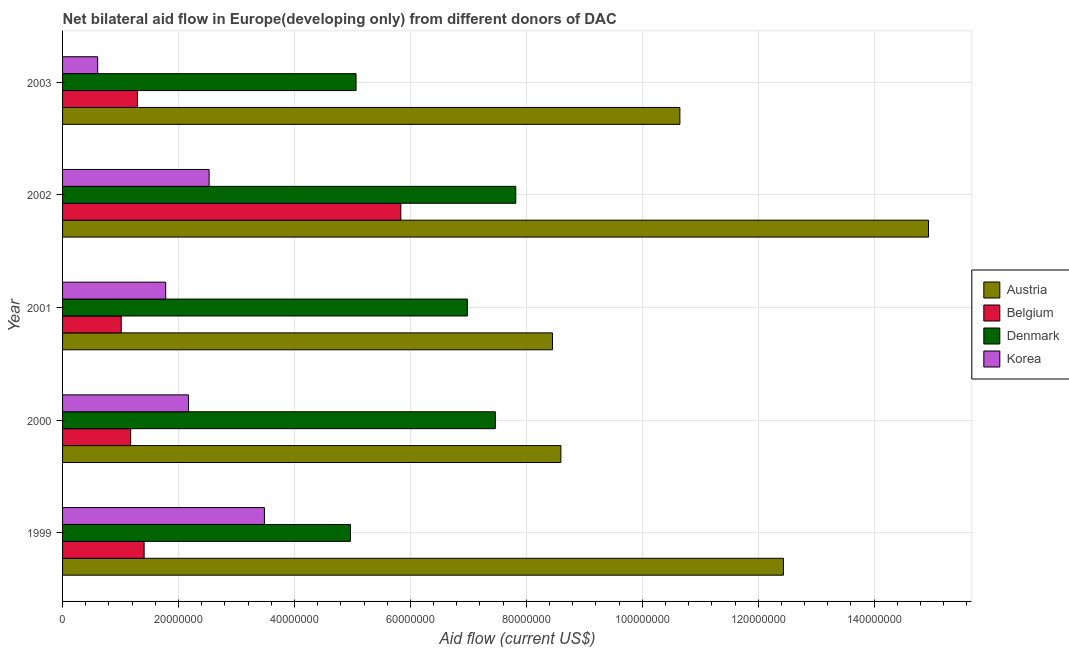How many bars are there on the 1st tick from the top?
Make the answer very short. 4. In how many cases, is the number of bars for a given year not equal to the number of legend labels?
Ensure brevity in your answer.  0. What is the amount of aid given by austria in 2000?
Offer a terse response. 8.60e+07. Across all years, what is the maximum amount of aid given by austria?
Provide a succinct answer. 1.49e+08. Across all years, what is the minimum amount of aid given by austria?
Give a very brief answer. 8.45e+07. What is the total amount of aid given by austria in the graph?
Your answer should be compact. 5.51e+08. What is the difference between the amount of aid given by austria in 2000 and that in 2001?
Your answer should be very brief. 1.44e+06. What is the difference between the amount of aid given by belgium in 2001 and the amount of aid given by korea in 1999?
Your answer should be compact. -2.47e+07. What is the average amount of aid given by belgium per year?
Give a very brief answer. 2.14e+07. In the year 2000, what is the difference between the amount of aid given by korea and amount of aid given by austria?
Ensure brevity in your answer.  -6.42e+07. What is the ratio of the amount of aid given by austria in 2001 to that in 2002?
Your answer should be compact. 0.57. Is the amount of aid given by belgium in 2001 less than that in 2002?
Make the answer very short. Yes. What is the difference between the highest and the second highest amount of aid given by denmark?
Give a very brief answer. 3.52e+06. What is the difference between the highest and the lowest amount of aid given by belgium?
Offer a terse response. 4.82e+07. Is the sum of the amount of aid given by denmark in 2002 and 2003 greater than the maximum amount of aid given by korea across all years?
Keep it short and to the point. Yes. Is it the case that in every year, the sum of the amount of aid given by austria and amount of aid given by denmark is greater than the sum of amount of aid given by korea and amount of aid given by belgium?
Your response must be concise. Yes. What does the 1st bar from the top in 2003 represents?
Make the answer very short. Korea. What does the 3rd bar from the bottom in 2000 represents?
Ensure brevity in your answer.  Denmark. How many bars are there?
Provide a short and direct response. 20. How many years are there in the graph?
Ensure brevity in your answer.  5. Are the values on the major ticks of X-axis written in scientific E-notation?
Your answer should be compact. No. Does the graph contain any zero values?
Ensure brevity in your answer.  No. Does the graph contain grids?
Ensure brevity in your answer.  Yes. Where does the legend appear in the graph?
Ensure brevity in your answer.  Center right. What is the title of the graph?
Provide a short and direct response. Net bilateral aid flow in Europe(developing only) from different donors of DAC. What is the label or title of the Y-axis?
Your answer should be compact. Year. What is the Aid flow (current US$) of Austria in 1999?
Your answer should be compact. 1.24e+08. What is the Aid flow (current US$) of Belgium in 1999?
Make the answer very short. 1.41e+07. What is the Aid flow (current US$) of Denmark in 1999?
Offer a terse response. 4.97e+07. What is the Aid flow (current US$) in Korea in 1999?
Your response must be concise. 3.48e+07. What is the Aid flow (current US$) of Austria in 2000?
Keep it short and to the point. 8.60e+07. What is the Aid flow (current US$) in Belgium in 2000?
Ensure brevity in your answer.  1.18e+07. What is the Aid flow (current US$) in Denmark in 2000?
Give a very brief answer. 7.47e+07. What is the Aid flow (current US$) of Korea in 2000?
Your response must be concise. 2.17e+07. What is the Aid flow (current US$) of Austria in 2001?
Your answer should be compact. 8.45e+07. What is the Aid flow (current US$) of Belgium in 2001?
Provide a short and direct response. 1.01e+07. What is the Aid flow (current US$) of Denmark in 2001?
Make the answer very short. 6.98e+07. What is the Aid flow (current US$) of Korea in 2001?
Your answer should be compact. 1.78e+07. What is the Aid flow (current US$) of Austria in 2002?
Ensure brevity in your answer.  1.49e+08. What is the Aid flow (current US$) in Belgium in 2002?
Keep it short and to the point. 5.84e+07. What is the Aid flow (current US$) of Denmark in 2002?
Give a very brief answer. 7.82e+07. What is the Aid flow (current US$) of Korea in 2002?
Give a very brief answer. 2.53e+07. What is the Aid flow (current US$) of Austria in 2003?
Ensure brevity in your answer.  1.06e+08. What is the Aid flow (current US$) of Belgium in 2003?
Provide a succinct answer. 1.29e+07. What is the Aid flow (current US$) of Denmark in 2003?
Provide a succinct answer. 5.06e+07. What is the Aid flow (current US$) of Korea in 2003?
Offer a terse response. 6.06e+06. Across all years, what is the maximum Aid flow (current US$) of Austria?
Your answer should be compact. 1.49e+08. Across all years, what is the maximum Aid flow (current US$) of Belgium?
Make the answer very short. 5.84e+07. Across all years, what is the maximum Aid flow (current US$) in Denmark?
Your answer should be compact. 7.82e+07. Across all years, what is the maximum Aid flow (current US$) of Korea?
Offer a very short reply. 3.48e+07. Across all years, what is the minimum Aid flow (current US$) in Austria?
Offer a very short reply. 8.45e+07. Across all years, what is the minimum Aid flow (current US$) of Belgium?
Your answer should be compact. 1.01e+07. Across all years, what is the minimum Aid flow (current US$) of Denmark?
Offer a very short reply. 4.97e+07. Across all years, what is the minimum Aid flow (current US$) of Korea?
Give a very brief answer. 6.06e+06. What is the total Aid flow (current US$) of Austria in the graph?
Offer a very short reply. 5.51e+08. What is the total Aid flow (current US$) in Belgium in the graph?
Offer a terse response. 1.07e+08. What is the total Aid flow (current US$) of Denmark in the graph?
Your answer should be very brief. 3.23e+08. What is the total Aid flow (current US$) of Korea in the graph?
Keep it short and to the point. 1.06e+08. What is the difference between the Aid flow (current US$) in Austria in 1999 and that in 2000?
Provide a short and direct response. 3.84e+07. What is the difference between the Aid flow (current US$) of Belgium in 1999 and that in 2000?
Keep it short and to the point. 2.32e+06. What is the difference between the Aid flow (current US$) in Denmark in 1999 and that in 2000?
Keep it short and to the point. -2.50e+07. What is the difference between the Aid flow (current US$) in Korea in 1999 and that in 2000?
Provide a short and direct response. 1.31e+07. What is the difference between the Aid flow (current US$) in Austria in 1999 and that in 2001?
Provide a short and direct response. 3.98e+07. What is the difference between the Aid flow (current US$) in Belgium in 1999 and that in 2001?
Provide a short and direct response. 3.95e+06. What is the difference between the Aid flow (current US$) in Denmark in 1999 and that in 2001?
Provide a short and direct response. -2.02e+07. What is the difference between the Aid flow (current US$) in Korea in 1999 and that in 2001?
Offer a terse response. 1.70e+07. What is the difference between the Aid flow (current US$) in Austria in 1999 and that in 2002?
Provide a short and direct response. -2.50e+07. What is the difference between the Aid flow (current US$) in Belgium in 1999 and that in 2002?
Your response must be concise. -4.43e+07. What is the difference between the Aid flow (current US$) of Denmark in 1999 and that in 2002?
Make the answer very short. -2.85e+07. What is the difference between the Aid flow (current US$) of Korea in 1999 and that in 2002?
Your answer should be very brief. 9.54e+06. What is the difference between the Aid flow (current US$) in Austria in 1999 and that in 2003?
Keep it short and to the point. 1.79e+07. What is the difference between the Aid flow (current US$) in Belgium in 1999 and that in 2003?
Make the answer very short. 1.16e+06. What is the difference between the Aid flow (current US$) of Denmark in 1999 and that in 2003?
Your answer should be compact. -9.70e+05. What is the difference between the Aid flow (current US$) of Korea in 1999 and that in 2003?
Your answer should be very brief. 2.88e+07. What is the difference between the Aid flow (current US$) in Austria in 2000 and that in 2001?
Your response must be concise. 1.44e+06. What is the difference between the Aid flow (current US$) in Belgium in 2000 and that in 2001?
Your answer should be compact. 1.63e+06. What is the difference between the Aid flow (current US$) in Denmark in 2000 and that in 2001?
Provide a succinct answer. 4.83e+06. What is the difference between the Aid flow (current US$) of Korea in 2000 and that in 2001?
Keep it short and to the point. 3.94e+06. What is the difference between the Aid flow (current US$) of Austria in 2000 and that in 2002?
Keep it short and to the point. -6.34e+07. What is the difference between the Aid flow (current US$) in Belgium in 2000 and that in 2002?
Provide a short and direct response. -4.66e+07. What is the difference between the Aid flow (current US$) of Denmark in 2000 and that in 2002?
Offer a very short reply. -3.52e+06. What is the difference between the Aid flow (current US$) in Korea in 2000 and that in 2002?
Provide a succinct answer. -3.55e+06. What is the difference between the Aid flow (current US$) in Austria in 2000 and that in 2003?
Keep it short and to the point. -2.05e+07. What is the difference between the Aid flow (current US$) in Belgium in 2000 and that in 2003?
Your answer should be compact. -1.16e+06. What is the difference between the Aid flow (current US$) in Denmark in 2000 and that in 2003?
Keep it short and to the point. 2.40e+07. What is the difference between the Aid flow (current US$) in Korea in 2000 and that in 2003?
Your response must be concise. 1.57e+07. What is the difference between the Aid flow (current US$) in Austria in 2001 and that in 2002?
Make the answer very short. -6.49e+07. What is the difference between the Aid flow (current US$) in Belgium in 2001 and that in 2002?
Offer a very short reply. -4.82e+07. What is the difference between the Aid flow (current US$) of Denmark in 2001 and that in 2002?
Keep it short and to the point. -8.35e+06. What is the difference between the Aid flow (current US$) of Korea in 2001 and that in 2002?
Make the answer very short. -7.49e+06. What is the difference between the Aid flow (current US$) of Austria in 2001 and that in 2003?
Keep it short and to the point. -2.20e+07. What is the difference between the Aid flow (current US$) in Belgium in 2001 and that in 2003?
Ensure brevity in your answer.  -2.79e+06. What is the difference between the Aid flow (current US$) in Denmark in 2001 and that in 2003?
Your answer should be very brief. 1.92e+07. What is the difference between the Aid flow (current US$) of Korea in 2001 and that in 2003?
Provide a short and direct response. 1.17e+07. What is the difference between the Aid flow (current US$) in Austria in 2002 and that in 2003?
Your response must be concise. 4.29e+07. What is the difference between the Aid flow (current US$) in Belgium in 2002 and that in 2003?
Make the answer very short. 4.54e+07. What is the difference between the Aid flow (current US$) in Denmark in 2002 and that in 2003?
Keep it short and to the point. 2.76e+07. What is the difference between the Aid flow (current US$) in Korea in 2002 and that in 2003?
Make the answer very short. 1.92e+07. What is the difference between the Aid flow (current US$) in Austria in 1999 and the Aid flow (current US$) in Belgium in 2000?
Keep it short and to the point. 1.13e+08. What is the difference between the Aid flow (current US$) in Austria in 1999 and the Aid flow (current US$) in Denmark in 2000?
Offer a terse response. 4.97e+07. What is the difference between the Aid flow (current US$) of Austria in 1999 and the Aid flow (current US$) of Korea in 2000?
Your response must be concise. 1.03e+08. What is the difference between the Aid flow (current US$) in Belgium in 1999 and the Aid flow (current US$) in Denmark in 2000?
Your answer should be very brief. -6.06e+07. What is the difference between the Aid flow (current US$) of Belgium in 1999 and the Aid flow (current US$) of Korea in 2000?
Offer a very short reply. -7.66e+06. What is the difference between the Aid flow (current US$) in Denmark in 1999 and the Aid flow (current US$) in Korea in 2000?
Keep it short and to the point. 2.79e+07. What is the difference between the Aid flow (current US$) in Austria in 1999 and the Aid flow (current US$) in Belgium in 2001?
Keep it short and to the point. 1.14e+08. What is the difference between the Aid flow (current US$) in Austria in 1999 and the Aid flow (current US$) in Denmark in 2001?
Make the answer very short. 5.45e+07. What is the difference between the Aid flow (current US$) in Austria in 1999 and the Aid flow (current US$) in Korea in 2001?
Offer a terse response. 1.07e+08. What is the difference between the Aid flow (current US$) of Belgium in 1999 and the Aid flow (current US$) of Denmark in 2001?
Offer a terse response. -5.58e+07. What is the difference between the Aid flow (current US$) of Belgium in 1999 and the Aid flow (current US$) of Korea in 2001?
Make the answer very short. -3.72e+06. What is the difference between the Aid flow (current US$) in Denmark in 1999 and the Aid flow (current US$) in Korea in 2001?
Your answer should be very brief. 3.19e+07. What is the difference between the Aid flow (current US$) of Austria in 1999 and the Aid flow (current US$) of Belgium in 2002?
Provide a succinct answer. 6.60e+07. What is the difference between the Aid flow (current US$) in Austria in 1999 and the Aid flow (current US$) in Denmark in 2002?
Make the answer very short. 4.62e+07. What is the difference between the Aid flow (current US$) of Austria in 1999 and the Aid flow (current US$) of Korea in 2002?
Keep it short and to the point. 9.91e+07. What is the difference between the Aid flow (current US$) in Belgium in 1999 and the Aid flow (current US$) in Denmark in 2002?
Ensure brevity in your answer.  -6.41e+07. What is the difference between the Aid flow (current US$) of Belgium in 1999 and the Aid flow (current US$) of Korea in 2002?
Your answer should be compact. -1.12e+07. What is the difference between the Aid flow (current US$) of Denmark in 1999 and the Aid flow (current US$) of Korea in 2002?
Provide a succinct answer. 2.44e+07. What is the difference between the Aid flow (current US$) in Austria in 1999 and the Aid flow (current US$) in Belgium in 2003?
Ensure brevity in your answer.  1.11e+08. What is the difference between the Aid flow (current US$) in Austria in 1999 and the Aid flow (current US$) in Denmark in 2003?
Your response must be concise. 7.37e+07. What is the difference between the Aid flow (current US$) in Austria in 1999 and the Aid flow (current US$) in Korea in 2003?
Your response must be concise. 1.18e+08. What is the difference between the Aid flow (current US$) of Belgium in 1999 and the Aid flow (current US$) of Denmark in 2003?
Your response must be concise. -3.66e+07. What is the difference between the Aid flow (current US$) of Belgium in 1999 and the Aid flow (current US$) of Korea in 2003?
Provide a short and direct response. 8.01e+06. What is the difference between the Aid flow (current US$) of Denmark in 1999 and the Aid flow (current US$) of Korea in 2003?
Your answer should be very brief. 4.36e+07. What is the difference between the Aid flow (current US$) of Austria in 2000 and the Aid flow (current US$) of Belgium in 2001?
Offer a terse response. 7.58e+07. What is the difference between the Aid flow (current US$) in Austria in 2000 and the Aid flow (current US$) in Denmark in 2001?
Offer a terse response. 1.61e+07. What is the difference between the Aid flow (current US$) in Austria in 2000 and the Aid flow (current US$) in Korea in 2001?
Your response must be concise. 6.82e+07. What is the difference between the Aid flow (current US$) in Belgium in 2000 and the Aid flow (current US$) in Denmark in 2001?
Offer a terse response. -5.81e+07. What is the difference between the Aid flow (current US$) of Belgium in 2000 and the Aid flow (current US$) of Korea in 2001?
Provide a succinct answer. -6.04e+06. What is the difference between the Aid flow (current US$) of Denmark in 2000 and the Aid flow (current US$) of Korea in 2001?
Offer a terse response. 5.69e+07. What is the difference between the Aid flow (current US$) in Austria in 2000 and the Aid flow (current US$) in Belgium in 2002?
Your answer should be compact. 2.76e+07. What is the difference between the Aid flow (current US$) of Austria in 2000 and the Aid flow (current US$) of Denmark in 2002?
Offer a terse response. 7.78e+06. What is the difference between the Aid flow (current US$) of Austria in 2000 and the Aid flow (current US$) of Korea in 2002?
Your answer should be compact. 6.07e+07. What is the difference between the Aid flow (current US$) in Belgium in 2000 and the Aid flow (current US$) in Denmark in 2002?
Provide a succinct answer. -6.64e+07. What is the difference between the Aid flow (current US$) in Belgium in 2000 and the Aid flow (current US$) in Korea in 2002?
Give a very brief answer. -1.35e+07. What is the difference between the Aid flow (current US$) in Denmark in 2000 and the Aid flow (current US$) in Korea in 2002?
Your answer should be compact. 4.94e+07. What is the difference between the Aid flow (current US$) of Austria in 2000 and the Aid flow (current US$) of Belgium in 2003?
Keep it short and to the point. 7.30e+07. What is the difference between the Aid flow (current US$) of Austria in 2000 and the Aid flow (current US$) of Denmark in 2003?
Make the answer very short. 3.53e+07. What is the difference between the Aid flow (current US$) of Austria in 2000 and the Aid flow (current US$) of Korea in 2003?
Provide a short and direct response. 7.99e+07. What is the difference between the Aid flow (current US$) in Belgium in 2000 and the Aid flow (current US$) in Denmark in 2003?
Your response must be concise. -3.89e+07. What is the difference between the Aid flow (current US$) in Belgium in 2000 and the Aid flow (current US$) in Korea in 2003?
Your answer should be very brief. 5.69e+06. What is the difference between the Aid flow (current US$) of Denmark in 2000 and the Aid flow (current US$) of Korea in 2003?
Offer a terse response. 6.86e+07. What is the difference between the Aid flow (current US$) of Austria in 2001 and the Aid flow (current US$) of Belgium in 2002?
Your answer should be compact. 2.62e+07. What is the difference between the Aid flow (current US$) in Austria in 2001 and the Aid flow (current US$) in Denmark in 2002?
Offer a very short reply. 6.34e+06. What is the difference between the Aid flow (current US$) in Austria in 2001 and the Aid flow (current US$) in Korea in 2002?
Ensure brevity in your answer.  5.92e+07. What is the difference between the Aid flow (current US$) of Belgium in 2001 and the Aid flow (current US$) of Denmark in 2002?
Your answer should be very brief. -6.81e+07. What is the difference between the Aid flow (current US$) of Belgium in 2001 and the Aid flow (current US$) of Korea in 2002?
Your response must be concise. -1.52e+07. What is the difference between the Aid flow (current US$) in Denmark in 2001 and the Aid flow (current US$) in Korea in 2002?
Your answer should be very brief. 4.46e+07. What is the difference between the Aid flow (current US$) in Austria in 2001 and the Aid flow (current US$) in Belgium in 2003?
Provide a succinct answer. 7.16e+07. What is the difference between the Aid flow (current US$) of Austria in 2001 and the Aid flow (current US$) of Denmark in 2003?
Your response must be concise. 3.39e+07. What is the difference between the Aid flow (current US$) of Austria in 2001 and the Aid flow (current US$) of Korea in 2003?
Make the answer very short. 7.85e+07. What is the difference between the Aid flow (current US$) of Belgium in 2001 and the Aid flow (current US$) of Denmark in 2003?
Give a very brief answer. -4.05e+07. What is the difference between the Aid flow (current US$) of Belgium in 2001 and the Aid flow (current US$) of Korea in 2003?
Provide a succinct answer. 4.06e+06. What is the difference between the Aid flow (current US$) in Denmark in 2001 and the Aid flow (current US$) in Korea in 2003?
Provide a short and direct response. 6.38e+07. What is the difference between the Aid flow (current US$) of Austria in 2002 and the Aid flow (current US$) of Belgium in 2003?
Offer a very short reply. 1.36e+08. What is the difference between the Aid flow (current US$) in Austria in 2002 and the Aid flow (current US$) in Denmark in 2003?
Your response must be concise. 9.88e+07. What is the difference between the Aid flow (current US$) of Austria in 2002 and the Aid flow (current US$) of Korea in 2003?
Make the answer very short. 1.43e+08. What is the difference between the Aid flow (current US$) in Belgium in 2002 and the Aid flow (current US$) in Denmark in 2003?
Offer a very short reply. 7.72e+06. What is the difference between the Aid flow (current US$) in Belgium in 2002 and the Aid flow (current US$) in Korea in 2003?
Your response must be concise. 5.23e+07. What is the difference between the Aid flow (current US$) of Denmark in 2002 and the Aid flow (current US$) of Korea in 2003?
Offer a terse response. 7.21e+07. What is the average Aid flow (current US$) of Austria per year?
Give a very brief answer. 1.10e+08. What is the average Aid flow (current US$) in Belgium per year?
Your answer should be compact. 2.14e+07. What is the average Aid flow (current US$) of Denmark per year?
Ensure brevity in your answer.  6.46e+07. What is the average Aid flow (current US$) in Korea per year?
Provide a short and direct response. 2.11e+07. In the year 1999, what is the difference between the Aid flow (current US$) in Austria and Aid flow (current US$) in Belgium?
Your answer should be very brief. 1.10e+08. In the year 1999, what is the difference between the Aid flow (current US$) of Austria and Aid flow (current US$) of Denmark?
Offer a terse response. 7.47e+07. In the year 1999, what is the difference between the Aid flow (current US$) in Austria and Aid flow (current US$) in Korea?
Ensure brevity in your answer.  8.95e+07. In the year 1999, what is the difference between the Aid flow (current US$) of Belgium and Aid flow (current US$) of Denmark?
Offer a terse response. -3.56e+07. In the year 1999, what is the difference between the Aid flow (current US$) in Belgium and Aid flow (current US$) in Korea?
Offer a very short reply. -2.08e+07. In the year 1999, what is the difference between the Aid flow (current US$) of Denmark and Aid flow (current US$) of Korea?
Provide a short and direct response. 1.48e+07. In the year 2000, what is the difference between the Aid flow (current US$) of Austria and Aid flow (current US$) of Belgium?
Offer a terse response. 7.42e+07. In the year 2000, what is the difference between the Aid flow (current US$) of Austria and Aid flow (current US$) of Denmark?
Offer a terse response. 1.13e+07. In the year 2000, what is the difference between the Aid flow (current US$) in Austria and Aid flow (current US$) in Korea?
Give a very brief answer. 6.42e+07. In the year 2000, what is the difference between the Aid flow (current US$) in Belgium and Aid flow (current US$) in Denmark?
Your answer should be very brief. -6.29e+07. In the year 2000, what is the difference between the Aid flow (current US$) in Belgium and Aid flow (current US$) in Korea?
Your response must be concise. -9.98e+06. In the year 2000, what is the difference between the Aid flow (current US$) of Denmark and Aid flow (current US$) of Korea?
Provide a succinct answer. 5.29e+07. In the year 2001, what is the difference between the Aid flow (current US$) of Austria and Aid flow (current US$) of Belgium?
Your answer should be compact. 7.44e+07. In the year 2001, what is the difference between the Aid flow (current US$) of Austria and Aid flow (current US$) of Denmark?
Give a very brief answer. 1.47e+07. In the year 2001, what is the difference between the Aid flow (current US$) in Austria and Aid flow (current US$) in Korea?
Keep it short and to the point. 6.67e+07. In the year 2001, what is the difference between the Aid flow (current US$) of Belgium and Aid flow (current US$) of Denmark?
Your answer should be very brief. -5.97e+07. In the year 2001, what is the difference between the Aid flow (current US$) of Belgium and Aid flow (current US$) of Korea?
Your response must be concise. -7.67e+06. In the year 2001, what is the difference between the Aid flow (current US$) of Denmark and Aid flow (current US$) of Korea?
Give a very brief answer. 5.20e+07. In the year 2002, what is the difference between the Aid flow (current US$) of Austria and Aid flow (current US$) of Belgium?
Your response must be concise. 9.10e+07. In the year 2002, what is the difference between the Aid flow (current US$) in Austria and Aid flow (current US$) in Denmark?
Your answer should be very brief. 7.12e+07. In the year 2002, what is the difference between the Aid flow (current US$) of Austria and Aid flow (current US$) of Korea?
Give a very brief answer. 1.24e+08. In the year 2002, what is the difference between the Aid flow (current US$) of Belgium and Aid flow (current US$) of Denmark?
Offer a very short reply. -1.98e+07. In the year 2002, what is the difference between the Aid flow (current US$) in Belgium and Aid flow (current US$) in Korea?
Provide a short and direct response. 3.31e+07. In the year 2002, what is the difference between the Aid flow (current US$) of Denmark and Aid flow (current US$) of Korea?
Give a very brief answer. 5.29e+07. In the year 2003, what is the difference between the Aid flow (current US$) in Austria and Aid flow (current US$) in Belgium?
Your answer should be compact. 9.36e+07. In the year 2003, what is the difference between the Aid flow (current US$) of Austria and Aid flow (current US$) of Denmark?
Make the answer very short. 5.59e+07. In the year 2003, what is the difference between the Aid flow (current US$) in Austria and Aid flow (current US$) in Korea?
Your response must be concise. 1.00e+08. In the year 2003, what is the difference between the Aid flow (current US$) of Belgium and Aid flow (current US$) of Denmark?
Provide a short and direct response. -3.77e+07. In the year 2003, what is the difference between the Aid flow (current US$) of Belgium and Aid flow (current US$) of Korea?
Offer a very short reply. 6.85e+06. In the year 2003, what is the difference between the Aid flow (current US$) of Denmark and Aid flow (current US$) of Korea?
Make the answer very short. 4.46e+07. What is the ratio of the Aid flow (current US$) of Austria in 1999 to that in 2000?
Provide a short and direct response. 1.45. What is the ratio of the Aid flow (current US$) in Belgium in 1999 to that in 2000?
Keep it short and to the point. 1.2. What is the ratio of the Aid flow (current US$) in Denmark in 1999 to that in 2000?
Your answer should be very brief. 0.67. What is the ratio of the Aid flow (current US$) of Korea in 1999 to that in 2000?
Keep it short and to the point. 1.6. What is the ratio of the Aid flow (current US$) in Austria in 1999 to that in 2001?
Ensure brevity in your answer.  1.47. What is the ratio of the Aid flow (current US$) in Belgium in 1999 to that in 2001?
Offer a terse response. 1.39. What is the ratio of the Aid flow (current US$) in Denmark in 1999 to that in 2001?
Your response must be concise. 0.71. What is the ratio of the Aid flow (current US$) in Korea in 1999 to that in 2001?
Offer a terse response. 1.96. What is the ratio of the Aid flow (current US$) in Austria in 1999 to that in 2002?
Provide a short and direct response. 0.83. What is the ratio of the Aid flow (current US$) of Belgium in 1999 to that in 2002?
Your response must be concise. 0.24. What is the ratio of the Aid flow (current US$) of Denmark in 1999 to that in 2002?
Keep it short and to the point. 0.64. What is the ratio of the Aid flow (current US$) of Korea in 1999 to that in 2002?
Your answer should be very brief. 1.38. What is the ratio of the Aid flow (current US$) of Austria in 1999 to that in 2003?
Offer a terse response. 1.17. What is the ratio of the Aid flow (current US$) of Belgium in 1999 to that in 2003?
Your answer should be compact. 1.09. What is the ratio of the Aid flow (current US$) of Denmark in 1999 to that in 2003?
Ensure brevity in your answer.  0.98. What is the ratio of the Aid flow (current US$) of Korea in 1999 to that in 2003?
Offer a terse response. 5.75. What is the ratio of the Aid flow (current US$) in Austria in 2000 to that in 2001?
Provide a succinct answer. 1.02. What is the ratio of the Aid flow (current US$) in Belgium in 2000 to that in 2001?
Give a very brief answer. 1.16. What is the ratio of the Aid flow (current US$) of Denmark in 2000 to that in 2001?
Ensure brevity in your answer.  1.07. What is the ratio of the Aid flow (current US$) of Korea in 2000 to that in 2001?
Provide a short and direct response. 1.22. What is the ratio of the Aid flow (current US$) of Austria in 2000 to that in 2002?
Offer a very short reply. 0.58. What is the ratio of the Aid flow (current US$) of Belgium in 2000 to that in 2002?
Your answer should be compact. 0.2. What is the ratio of the Aid flow (current US$) of Denmark in 2000 to that in 2002?
Give a very brief answer. 0.95. What is the ratio of the Aid flow (current US$) of Korea in 2000 to that in 2002?
Offer a terse response. 0.86. What is the ratio of the Aid flow (current US$) of Austria in 2000 to that in 2003?
Your answer should be compact. 0.81. What is the ratio of the Aid flow (current US$) of Belgium in 2000 to that in 2003?
Your response must be concise. 0.91. What is the ratio of the Aid flow (current US$) in Denmark in 2000 to that in 2003?
Give a very brief answer. 1.47. What is the ratio of the Aid flow (current US$) in Korea in 2000 to that in 2003?
Your response must be concise. 3.59. What is the ratio of the Aid flow (current US$) in Austria in 2001 to that in 2002?
Make the answer very short. 0.57. What is the ratio of the Aid flow (current US$) of Belgium in 2001 to that in 2002?
Provide a succinct answer. 0.17. What is the ratio of the Aid flow (current US$) in Denmark in 2001 to that in 2002?
Your response must be concise. 0.89. What is the ratio of the Aid flow (current US$) in Korea in 2001 to that in 2002?
Provide a succinct answer. 0.7. What is the ratio of the Aid flow (current US$) of Austria in 2001 to that in 2003?
Offer a terse response. 0.79. What is the ratio of the Aid flow (current US$) of Belgium in 2001 to that in 2003?
Ensure brevity in your answer.  0.78. What is the ratio of the Aid flow (current US$) in Denmark in 2001 to that in 2003?
Offer a terse response. 1.38. What is the ratio of the Aid flow (current US$) in Korea in 2001 to that in 2003?
Offer a terse response. 2.94. What is the ratio of the Aid flow (current US$) in Austria in 2002 to that in 2003?
Give a very brief answer. 1.4. What is the ratio of the Aid flow (current US$) of Belgium in 2002 to that in 2003?
Your response must be concise. 4.52. What is the ratio of the Aid flow (current US$) in Denmark in 2002 to that in 2003?
Offer a terse response. 1.54. What is the ratio of the Aid flow (current US$) in Korea in 2002 to that in 2003?
Offer a very short reply. 4.17. What is the difference between the highest and the second highest Aid flow (current US$) in Austria?
Your answer should be very brief. 2.50e+07. What is the difference between the highest and the second highest Aid flow (current US$) of Belgium?
Ensure brevity in your answer.  4.43e+07. What is the difference between the highest and the second highest Aid flow (current US$) of Denmark?
Offer a terse response. 3.52e+06. What is the difference between the highest and the second highest Aid flow (current US$) of Korea?
Offer a very short reply. 9.54e+06. What is the difference between the highest and the lowest Aid flow (current US$) in Austria?
Your answer should be compact. 6.49e+07. What is the difference between the highest and the lowest Aid flow (current US$) of Belgium?
Your answer should be compact. 4.82e+07. What is the difference between the highest and the lowest Aid flow (current US$) in Denmark?
Provide a succinct answer. 2.85e+07. What is the difference between the highest and the lowest Aid flow (current US$) in Korea?
Provide a succinct answer. 2.88e+07. 